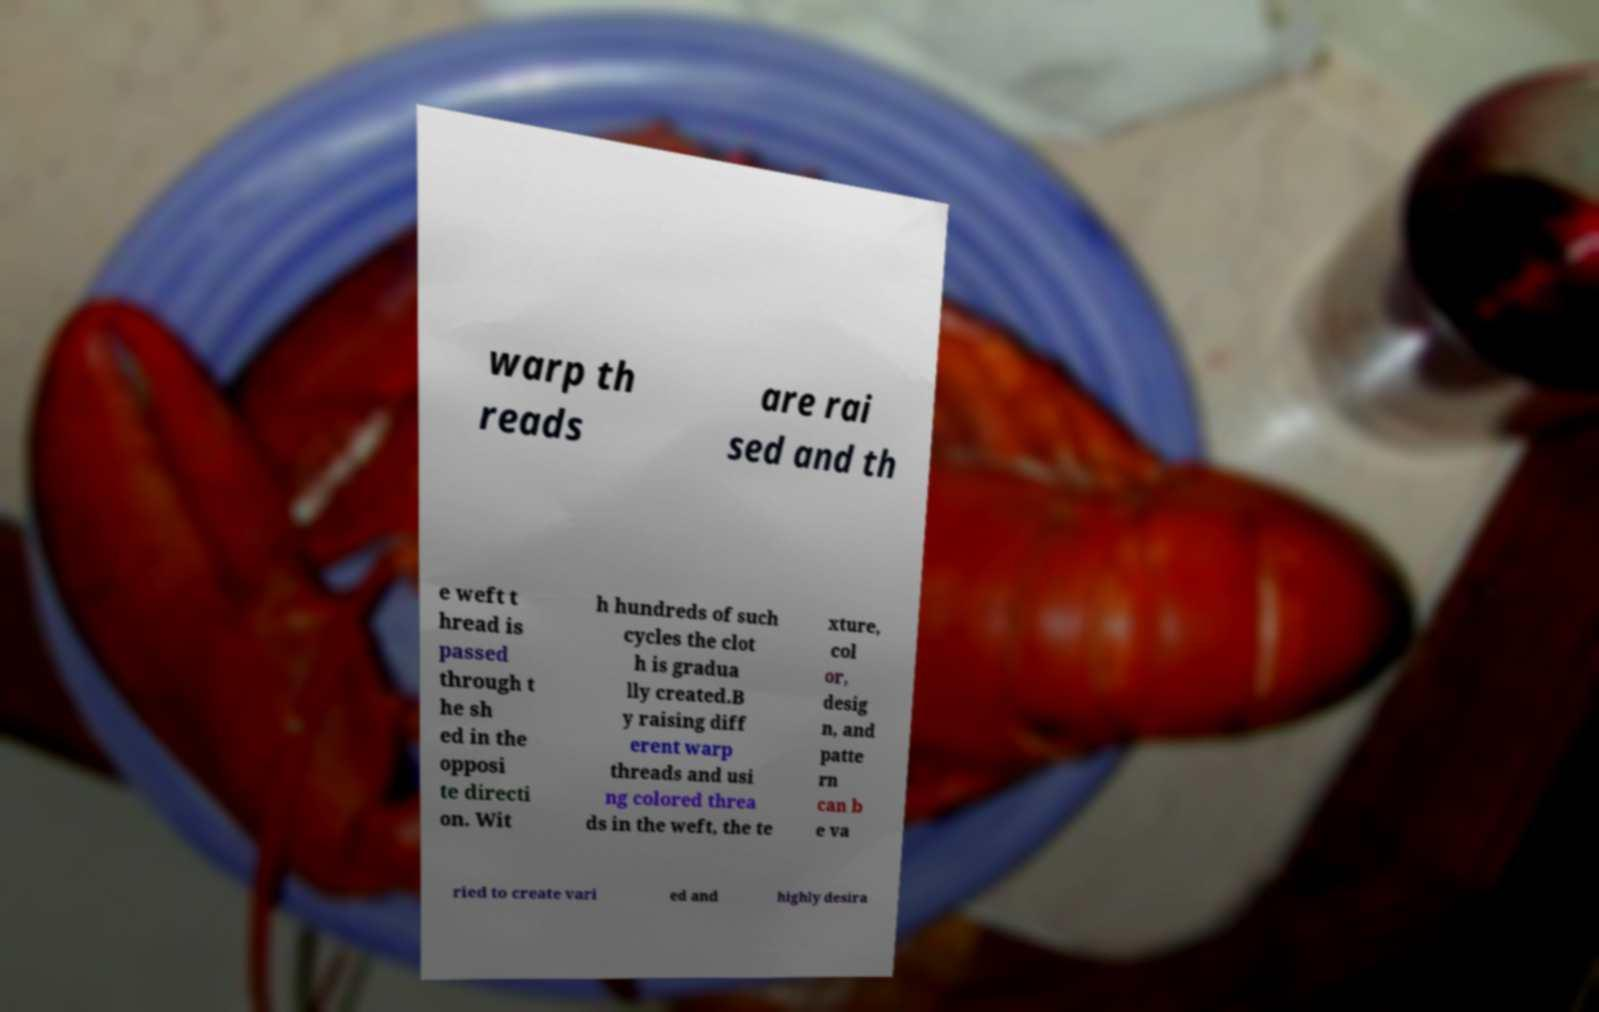Please identify and transcribe the text found in this image. warp th reads are rai sed and th e weft t hread is passed through t he sh ed in the opposi te directi on. Wit h hundreds of such cycles the clot h is gradua lly created.B y raising diff erent warp threads and usi ng colored threa ds in the weft, the te xture, col or, desig n, and patte rn can b e va ried to create vari ed and highly desira 